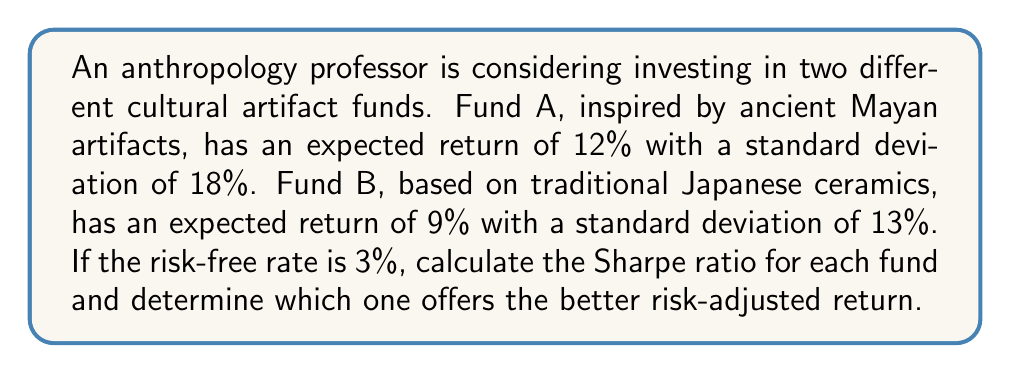Show me your answer to this math problem. To solve this problem, we need to calculate the Sharpe ratio for each fund. The Sharpe ratio is a measure of risk-adjusted return and is calculated using the following formula:

$$ \text{Sharpe Ratio} = \frac{R_p - R_f}{\sigma_p} $$

Where:
$R_p$ = Expected return of the portfolio
$R_f$ = Risk-free rate
$\sigma_p$ = Standard deviation of the portfolio (measure of risk)

Let's calculate the Sharpe ratio for each fund:

1. For Fund A (Mayan artifacts):
   $R_p = 12\%$
   $R_f = 3\%$
   $\sigma_p = 18\%$

   Sharpe Ratio A = $\frac{12\% - 3\%}{18\%} = \frac{9\%}{18\%} = 0.5$

2. For Fund B (Japanese ceramics):
   $R_p = 9\%$
   $R_f = 3\%$
   $\sigma_p = 13\%$

   Sharpe Ratio B = $\frac{9\% - 3\%}{13\%} = \frac{6\%}{13\%} \approx 0.4615$

The higher the Sharpe ratio, the better the risk-adjusted return. In this case, Fund A has a higher Sharpe ratio (0.5) compared to Fund B (0.4615), indicating that Fund A offers a better risk-adjusted return.
Answer: Fund A (Mayan artifacts) has a Sharpe ratio of 0.5, while Fund B (Japanese ceramics) has a Sharpe ratio of approximately 0.4615. Fund A offers the better risk-adjusted return. 